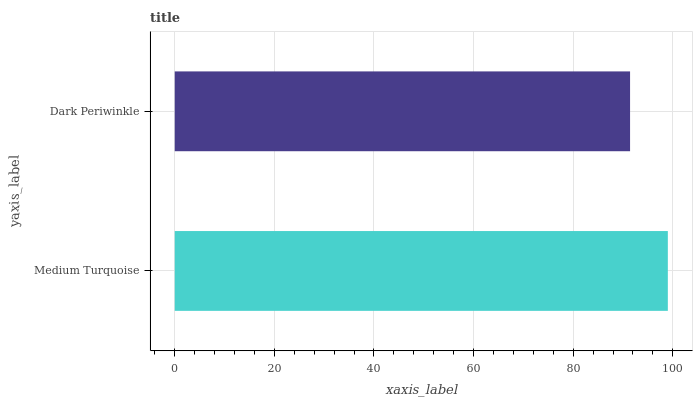Is Dark Periwinkle the minimum?
Answer yes or no. Yes. Is Medium Turquoise the maximum?
Answer yes or no. Yes. Is Dark Periwinkle the maximum?
Answer yes or no. No. Is Medium Turquoise greater than Dark Periwinkle?
Answer yes or no. Yes. Is Dark Periwinkle less than Medium Turquoise?
Answer yes or no. Yes. Is Dark Periwinkle greater than Medium Turquoise?
Answer yes or no. No. Is Medium Turquoise less than Dark Periwinkle?
Answer yes or no. No. Is Medium Turquoise the high median?
Answer yes or no. Yes. Is Dark Periwinkle the low median?
Answer yes or no. Yes. Is Dark Periwinkle the high median?
Answer yes or no. No. Is Medium Turquoise the low median?
Answer yes or no. No. 